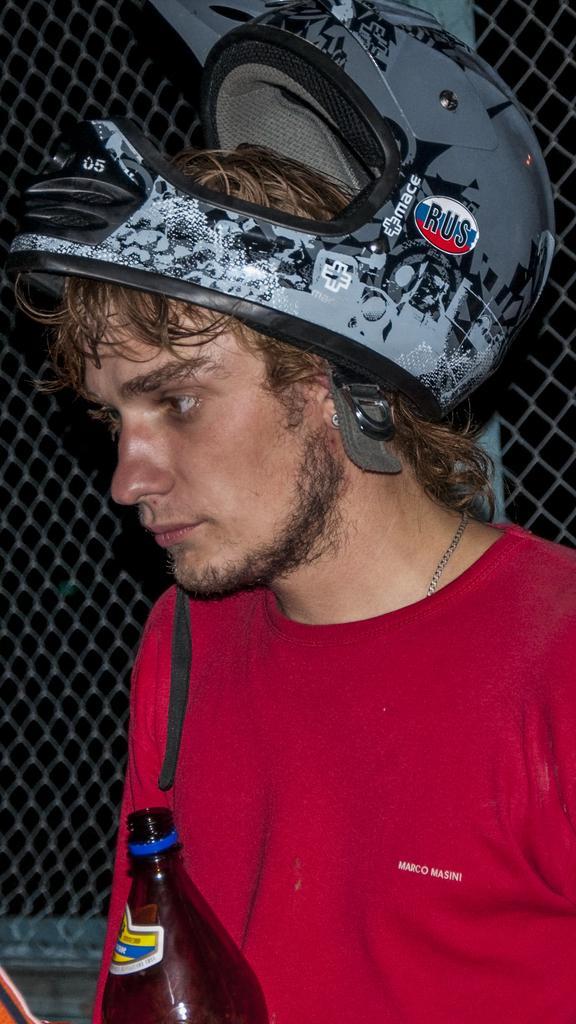Please provide a concise description of this image. In this image there is a man wearing red T-shirt and helmet on his head. This is a bottle which is brown in color. At background I can see a fencing gate. 